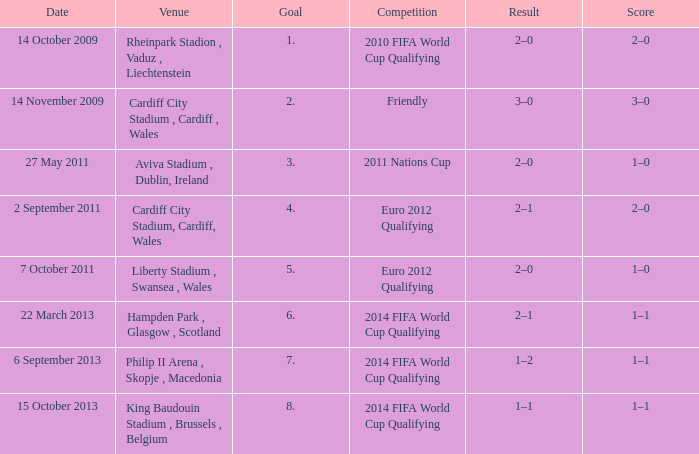What is the Venue for Goal number 1? Rheinpark Stadion , Vaduz , Liechtenstein. 